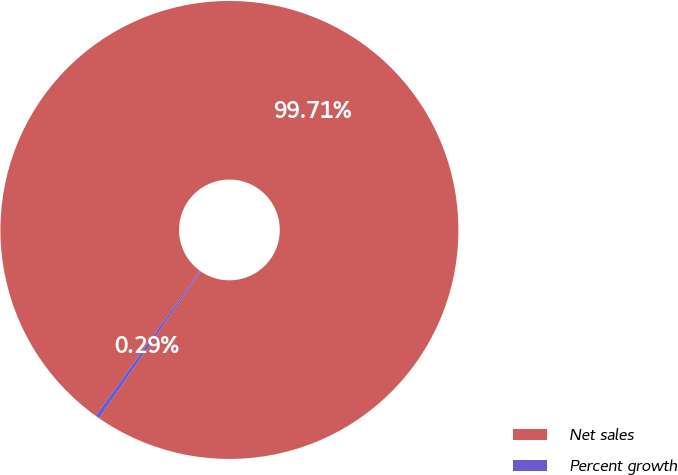<chart> <loc_0><loc_0><loc_500><loc_500><pie_chart><fcel>Net sales<fcel>Percent growth<nl><fcel>99.71%<fcel>0.29%<nl></chart> 